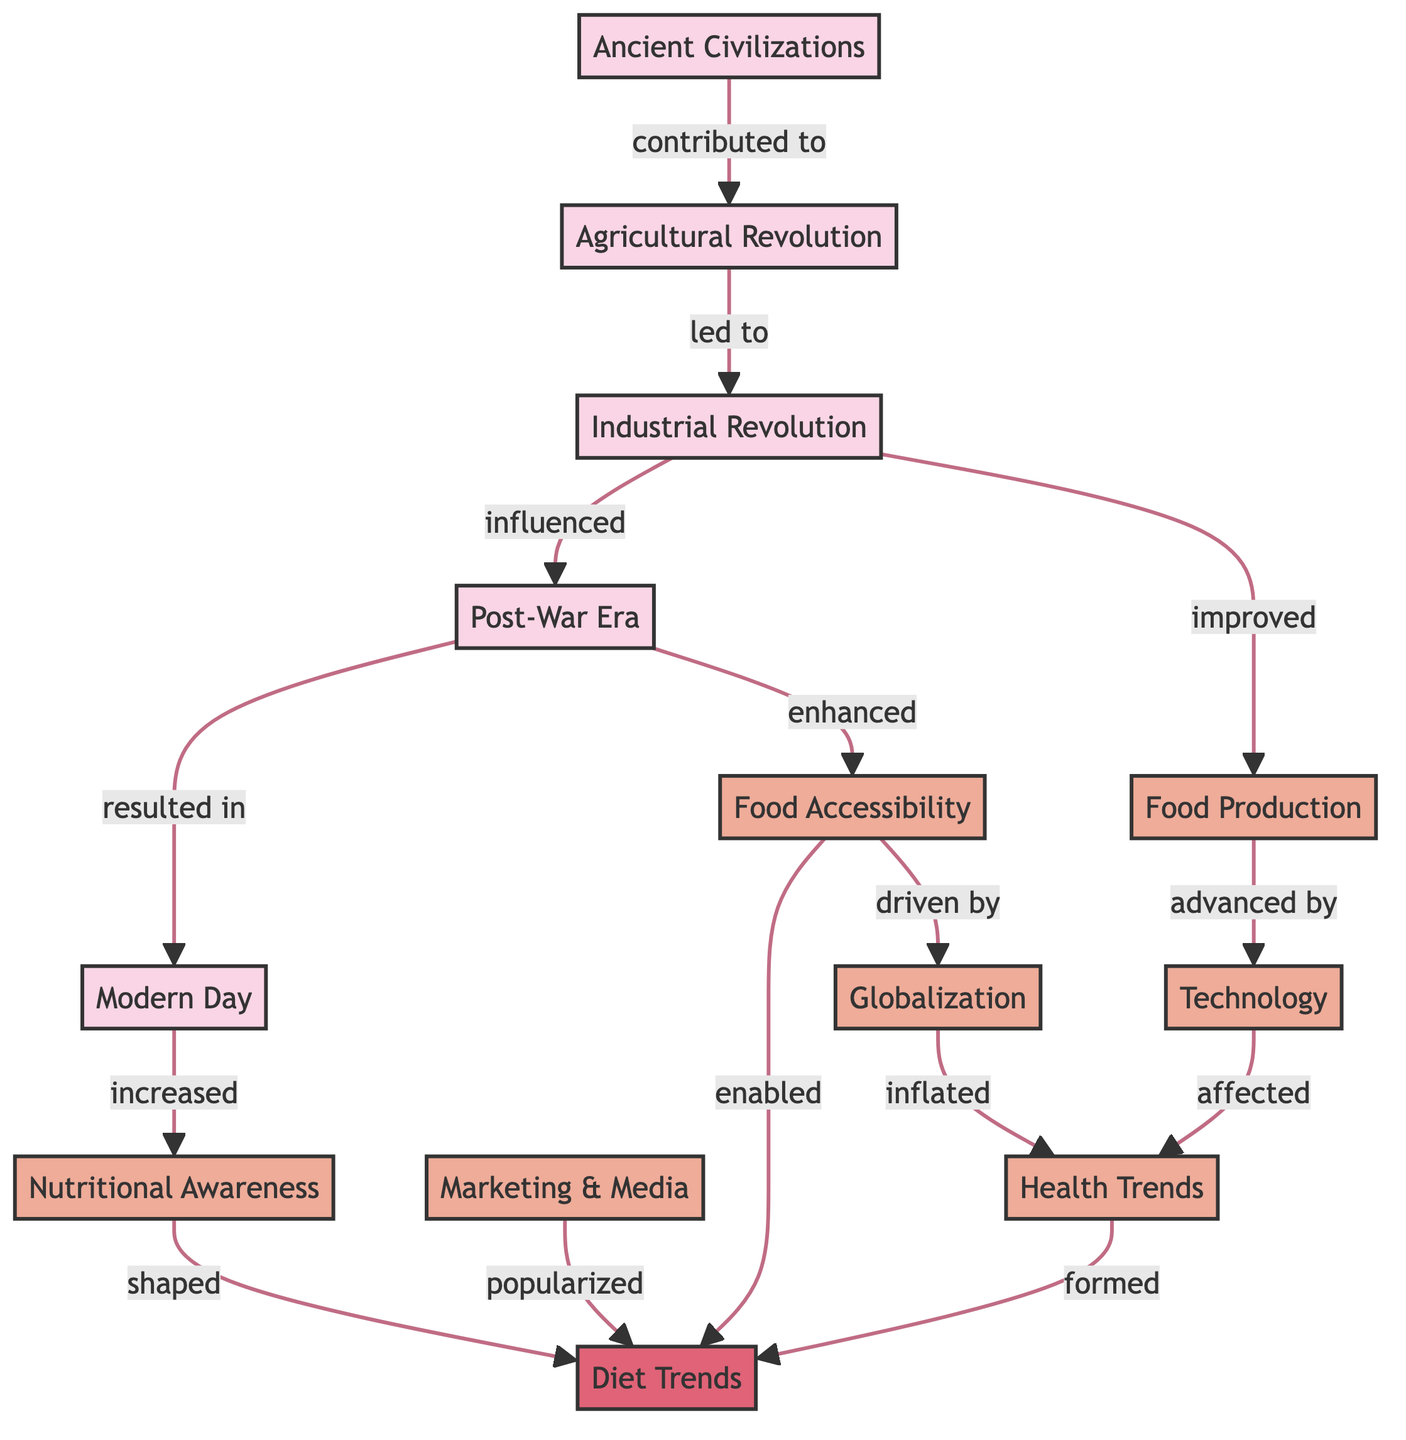What are the nodes representing historical periods? The nodes representing historical periods are "Ancient Civilizations," "Agricultural Revolution," "Industrial Revolution," "Post-War Era," and "Modern Day."
Answer: Ancient Civilizations, Agricultural Revolution, Industrial Revolution, Post-War Era, Modern Day Which factors resulted in increased dietary awareness in modern times? The factors that resulted in increased dietary awareness in modern times include "Food Accessibility" and "Nutritional Awareness," both contributing to the development of "Diet Trends."
Answer: Food Accessibility, Nutritional Awareness What is the influence of marketing and media on diet trends? Marketing and Media "popularized" diet trends by making them more visible and appealing to the public, thereby impacting consumer choices.
Answer: Popularized How many historical nodes are present in the diagram? There are five historical nodes present in the diagram, including all periods from Ancient Civilizations to Modern Day.
Answer: 5 Which node is directly influenced by the Industrial Revolution? The "Post-War Era" node is directly influenced by the "Industrial Revolution," showcasing the evolutionary impact of industrial changes.
Answer: Post-War Era What factors contribute to the development of diet trends? The factors contributing to the development of diet trends include "Food Accessibility," "Nutritional Awareness," "Marketing & Media," and "Health Trends."
Answer: Food Accessibility, Nutritional Awareness, Marketing & Media, Health Trends How does globalization affect diet trends? Globalization "inflated" health trends, showing how the interconnected global environment can alter diet trends and preferences by introducing diverse influences.
Answer: Inflated What historical event led to the enhancement of food accessibility? The "Post-War Era" led to the enhancement of food accessibility, marking a significant shift in how food is accessed and consumed by society.
Answer: Post-War Era Which node is affected by technology? The "Health Trends" node is affected by technology, indicating that advancements have played a role in shaping contemporary dietary trends and practices.
Answer: Health Trends 